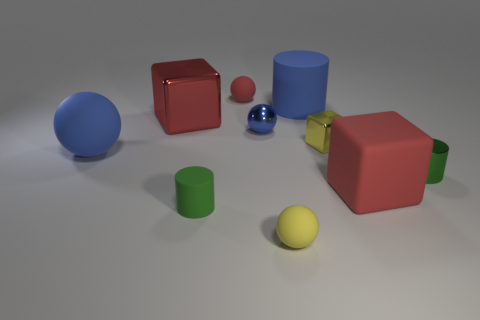Subtract all blocks. How many objects are left? 7 Subtract all tiny gray matte objects. Subtract all tiny red things. How many objects are left? 9 Add 8 red spheres. How many red spheres are left? 9 Add 1 matte things. How many matte things exist? 7 Subtract 0 cyan spheres. How many objects are left? 10 